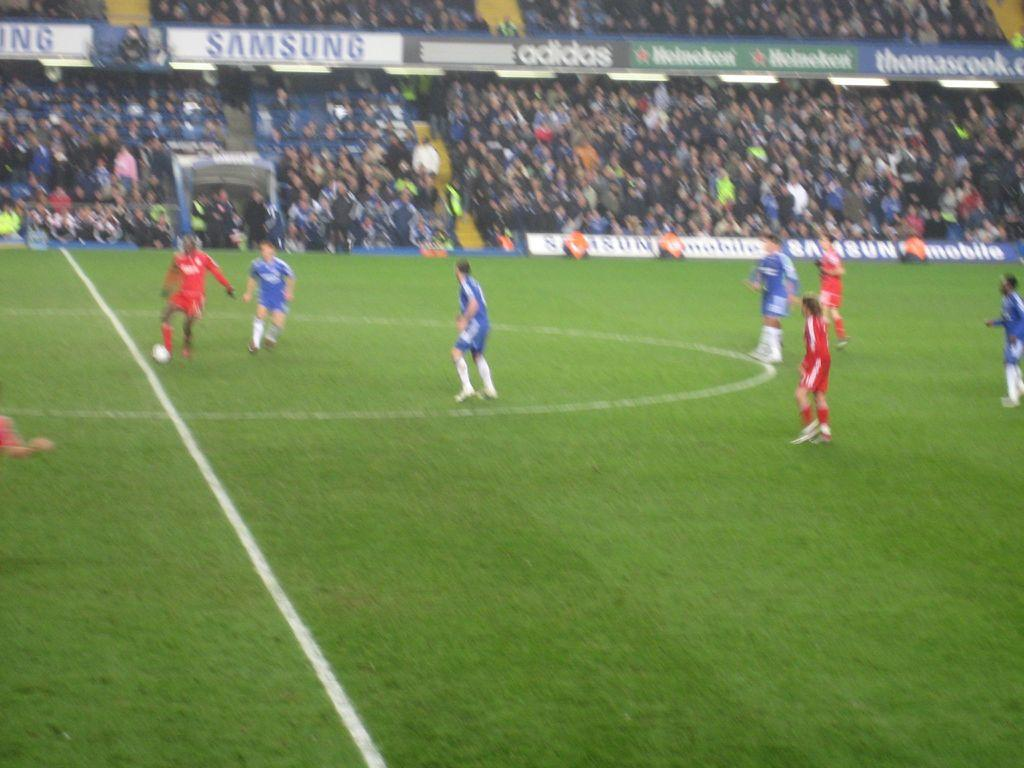Provide a one-sentence caption for the provided image. A soccer field with players wearing either blue or red jerseys and Samsung as a sponsor. 